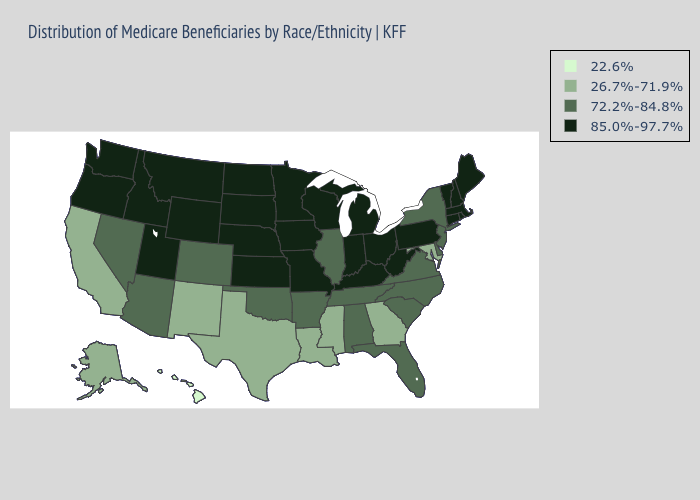What is the value of Florida?
Short answer required. 72.2%-84.8%. Does Rhode Island have a higher value than New Mexico?
Quick response, please. Yes. Does Nebraska have the highest value in the USA?
Give a very brief answer. Yes. Does South Dakota have a lower value than New Mexico?
Quick response, please. No. Does Minnesota have the same value as Alaska?
Concise answer only. No. What is the value of Maryland?
Answer briefly. 26.7%-71.9%. Which states have the highest value in the USA?
Give a very brief answer. Connecticut, Idaho, Indiana, Iowa, Kansas, Kentucky, Maine, Massachusetts, Michigan, Minnesota, Missouri, Montana, Nebraska, New Hampshire, North Dakota, Ohio, Oregon, Pennsylvania, Rhode Island, South Dakota, Utah, Vermont, Washington, West Virginia, Wisconsin, Wyoming. What is the value of Virginia?
Give a very brief answer. 72.2%-84.8%. Does Tennessee have the same value as Iowa?
Concise answer only. No. Name the states that have a value in the range 26.7%-71.9%?
Keep it brief. Alaska, California, Georgia, Louisiana, Maryland, Mississippi, New Mexico, Texas. What is the lowest value in states that border Washington?
Short answer required. 85.0%-97.7%. Among the states that border Nebraska , which have the highest value?
Give a very brief answer. Iowa, Kansas, Missouri, South Dakota, Wyoming. What is the value of South Carolina?
Be succinct. 72.2%-84.8%. What is the value of Ohio?
Quick response, please. 85.0%-97.7%. What is the value of Utah?
Short answer required. 85.0%-97.7%. 